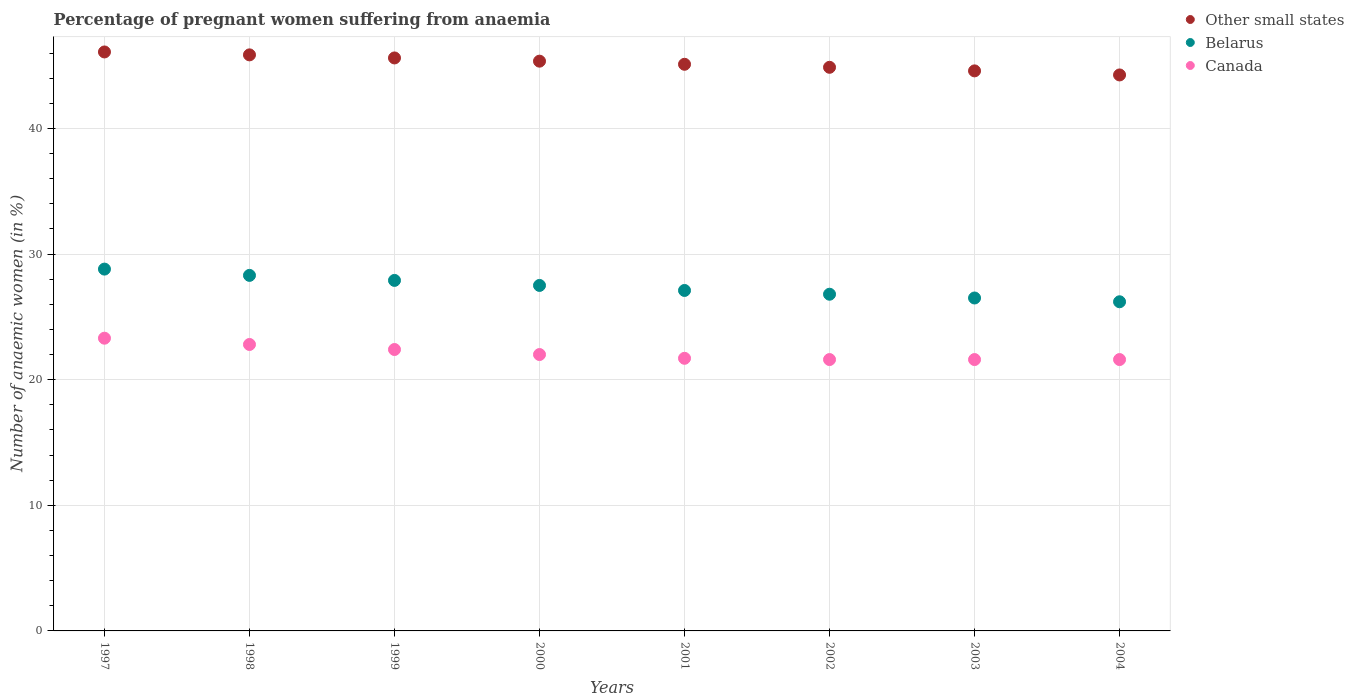How many different coloured dotlines are there?
Keep it short and to the point. 3. Is the number of dotlines equal to the number of legend labels?
Offer a terse response. Yes. What is the number of anaemic women in Belarus in 1998?
Offer a terse response. 28.3. Across all years, what is the maximum number of anaemic women in Canada?
Your answer should be compact. 23.3. Across all years, what is the minimum number of anaemic women in Canada?
Your response must be concise. 21.6. In which year was the number of anaemic women in Canada maximum?
Give a very brief answer. 1997. What is the total number of anaemic women in Belarus in the graph?
Offer a very short reply. 219.1. What is the difference between the number of anaemic women in Other small states in 2002 and the number of anaemic women in Canada in 2000?
Make the answer very short. 22.86. What is the average number of anaemic women in Canada per year?
Your answer should be compact. 22.12. In the year 2001, what is the difference between the number of anaemic women in Canada and number of anaemic women in Other small states?
Your answer should be very brief. -23.4. In how many years, is the number of anaemic women in Belarus greater than 24 %?
Your answer should be compact. 8. What is the ratio of the number of anaemic women in Other small states in 1998 to that in 2004?
Your answer should be very brief. 1.04. Is the number of anaemic women in Canada in 1998 less than that in 2002?
Ensure brevity in your answer.  No. What is the difference between the highest and the second highest number of anaemic women in Other small states?
Your response must be concise. 0.23. What is the difference between the highest and the lowest number of anaemic women in Canada?
Your response must be concise. 1.7. In how many years, is the number of anaemic women in Other small states greater than the average number of anaemic women in Other small states taken over all years?
Offer a very short reply. 4. Is the number of anaemic women in Belarus strictly greater than the number of anaemic women in Other small states over the years?
Offer a terse response. No. Is the number of anaemic women in Other small states strictly less than the number of anaemic women in Belarus over the years?
Offer a terse response. No. How many years are there in the graph?
Make the answer very short. 8. Where does the legend appear in the graph?
Provide a succinct answer. Top right. How are the legend labels stacked?
Offer a terse response. Vertical. What is the title of the graph?
Your answer should be very brief. Percentage of pregnant women suffering from anaemia. Does "Malawi" appear as one of the legend labels in the graph?
Your answer should be compact. No. What is the label or title of the X-axis?
Provide a short and direct response. Years. What is the label or title of the Y-axis?
Your response must be concise. Number of anaemic women (in %). What is the Number of anaemic women (in %) in Other small states in 1997?
Your answer should be very brief. 46.08. What is the Number of anaemic women (in %) in Belarus in 1997?
Offer a terse response. 28.8. What is the Number of anaemic women (in %) in Canada in 1997?
Offer a terse response. 23.3. What is the Number of anaemic women (in %) of Other small states in 1998?
Give a very brief answer. 45.85. What is the Number of anaemic women (in %) of Belarus in 1998?
Your answer should be compact. 28.3. What is the Number of anaemic women (in %) in Canada in 1998?
Provide a succinct answer. 22.8. What is the Number of anaemic women (in %) of Other small states in 1999?
Make the answer very short. 45.61. What is the Number of anaemic women (in %) of Belarus in 1999?
Offer a terse response. 27.9. What is the Number of anaemic women (in %) of Canada in 1999?
Make the answer very short. 22.4. What is the Number of anaemic women (in %) of Other small states in 2000?
Ensure brevity in your answer.  45.35. What is the Number of anaemic women (in %) in Belarus in 2000?
Your answer should be compact. 27.5. What is the Number of anaemic women (in %) of Other small states in 2001?
Give a very brief answer. 45.1. What is the Number of anaemic women (in %) in Belarus in 2001?
Ensure brevity in your answer.  27.1. What is the Number of anaemic women (in %) in Canada in 2001?
Offer a terse response. 21.7. What is the Number of anaemic women (in %) in Other small states in 2002?
Ensure brevity in your answer.  44.86. What is the Number of anaemic women (in %) in Belarus in 2002?
Keep it short and to the point. 26.8. What is the Number of anaemic women (in %) in Canada in 2002?
Keep it short and to the point. 21.6. What is the Number of anaemic women (in %) of Other small states in 2003?
Offer a very short reply. 44.58. What is the Number of anaemic women (in %) of Belarus in 2003?
Your answer should be compact. 26.5. What is the Number of anaemic women (in %) of Canada in 2003?
Keep it short and to the point. 21.6. What is the Number of anaemic women (in %) in Other small states in 2004?
Ensure brevity in your answer.  44.25. What is the Number of anaemic women (in %) of Belarus in 2004?
Your answer should be very brief. 26.2. What is the Number of anaemic women (in %) in Canada in 2004?
Ensure brevity in your answer.  21.6. Across all years, what is the maximum Number of anaemic women (in %) of Other small states?
Ensure brevity in your answer.  46.08. Across all years, what is the maximum Number of anaemic women (in %) of Belarus?
Offer a very short reply. 28.8. Across all years, what is the maximum Number of anaemic women (in %) of Canada?
Make the answer very short. 23.3. Across all years, what is the minimum Number of anaemic women (in %) in Other small states?
Keep it short and to the point. 44.25. Across all years, what is the minimum Number of anaemic women (in %) in Belarus?
Make the answer very short. 26.2. Across all years, what is the minimum Number of anaemic women (in %) of Canada?
Offer a very short reply. 21.6. What is the total Number of anaemic women (in %) of Other small states in the graph?
Your response must be concise. 361.7. What is the total Number of anaemic women (in %) in Belarus in the graph?
Your response must be concise. 219.1. What is the total Number of anaemic women (in %) in Canada in the graph?
Offer a terse response. 177. What is the difference between the Number of anaemic women (in %) of Other small states in 1997 and that in 1998?
Ensure brevity in your answer.  0.23. What is the difference between the Number of anaemic women (in %) in Belarus in 1997 and that in 1998?
Provide a succinct answer. 0.5. What is the difference between the Number of anaemic women (in %) in Other small states in 1997 and that in 1999?
Your answer should be very brief. 0.48. What is the difference between the Number of anaemic women (in %) of Belarus in 1997 and that in 1999?
Give a very brief answer. 0.9. What is the difference between the Number of anaemic women (in %) in Canada in 1997 and that in 1999?
Provide a succinct answer. 0.9. What is the difference between the Number of anaemic women (in %) of Other small states in 1997 and that in 2000?
Offer a very short reply. 0.73. What is the difference between the Number of anaemic women (in %) of Canada in 1997 and that in 2000?
Your answer should be very brief. 1.3. What is the difference between the Number of anaemic women (in %) in Other small states in 1997 and that in 2001?
Offer a very short reply. 0.98. What is the difference between the Number of anaemic women (in %) in Belarus in 1997 and that in 2001?
Your answer should be very brief. 1.7. What is the difference between the Number of anaemic women (in %) of Other small states in 1997 and that in 2002?
Keep it short and to the point. 1.22. What is the difference between the Number of anaemic women (in %) of Belarus in 1997 and that in 2002?
Provide a succinct answer. 2. What is the difference between the Number of anaemic women (in %) in Other small states in 1997 and that in 2003?
Your response must be concise. 1.51. What is the difference between the Number of anaemic women (in %) in Belarus in 1997 and that in 2003?
Give a very brief answer. 2.3. What is the difference between the Number of anaemic women (in %) of Canada in 1997 and that in 2003?
Keep it short and to the point. 1.7. What is the difference between the Number of anaemic women (in %) in Other small states in 1997 and that in 2004?
Ensure brevity in your answer.  1.83. What is the difference between the Number of anaemic women (in %) in Other small states in 1998 and that in 1999?
Make the answer very short. 0.24. What is the difference between the Number of anaemic women (in %) in Belarus in 1998 and that in 1999?
Offer a terse response. 0.4. What is the difference between the Number of anaemic women (in %) of Other small states in 1998 and that in 2000?
Give a very brief answer. 0.5. What is the difference between the Number of anaemic women (in %) in Canada in 1998 and that in 2000?
Your answer should be compact. 0.8. What is the difference between the Number of anaemic women (in %) of Other small states in 1998 and that in 2001?
Your answer should be compact. 0.75. What is the difference between the Number of anaemic women (in %) in Other small states in 1998 and that in 2002?
Provide a succinct answer. 0.99. What is the difference between the Number of anaemic women (in %) of Other small states in 1998 and that in 2003?
Your answer should be compact. 1.27. What is the difference between the Number of anaemic women (in %) in Belarus in 1998 and that in 2003?
Your answer should be compact. 1.8. What is the difference between the Number of anaemic women (in %) in Other small states in 1998 and that in 2004?
Ensure brevity in your answer.  1.6. What is the difference between the Number of anaemic women (in %) in Other small states in 1999 and that in 2000?
Offer a very short reply. 0.26. What is the difference between the Number of anaemic women (in %) in Other small states in 1999 and that in 2001?
Give a very brief answer. 0.5. What is the difference between the Number of anaemic women (in %) in Belarus in 1999 and that in 2001?
Make the answer very short. 0.8. What is the difference between the Number of anaemic women (in %) of Canada in 1999 and that in 2001?
Offer a terse response. 0.7. What is the difference between the Number of anaemic women (in %) of Other small states in 1999 and that in 2002?
Give a very brief answer. 0.75. What is the difference between the Number of anaemic women (in %) in Belarus in 1999 and that in 2002?
Provide a short and direct response. 1.1. What is the difference between the Number of anaemic women (in %) in Other small states in 1999 and that in 2003?
Offer a very short reply. 1.03. What is the difference between the Number of anaemic women (in %) in Belarus in 1999 and that in 2003?
Offer a very short reply. 1.4. What is the difference between the Number of anaemic women (in %) of Canada in 1999 and that in 2003?
Your answer should be compact. 0.8. What is the difference between the Number of anaemic women (in %) in Other small states in 1999 and that in 2004?
Provide a short and direct response. 1.35. What is the difference between the Number of anaemic women (in %) of Canada in 1999 and that in 2004?
Give a very brief answer. 0.8. What is the difference between the Number of anaemic women (in %) of Other small states in 2000 and that in 2001?
Ensure brevity in your answer.  0.25. What is the difference between the Number of anaemic women (in %) in Other small states in 2000 and that in 2002?
Keep it short and to the point. 0.49. What is the difference between the Number of anaemic women (in %) in Belarus in 2000 and that in 2002?
Ensure brevity in your answer.  0.7. What is the difference between the Number of anaemic women (in %) of Other small states in 2000 and that in 2003?
Your response must be concise. 0.77. What is the difference between the Number of anaemic women (in %) of Belarus in 2000 and that in 2003?
Ensure brevity in your answer.  1. What is the difference between the Number of anaemic women (in %) in Canada in 2000 and that in 2003?
Offer a terse response. 0.4. What is the difference between the Number of anaemic women (in %) of Other small states in 2000 and that in 2004?
Give a very brief answer. 1.1. What is the difference between the Number of anaemic women (in %) in Belarus in 2000 and that in 2004?
Offer a very short reply. 1.3. What is the difference between the Number of anaemic women (in %) in Canada in 2000 and that in 2004?
Your response must be concise. 0.4. What is the difference between the Number of anaemic women (in %) in Other small states in 2001 and that in 2002?
Make the answer very short. 0.24. What is the difference between the Number of anaemic women (in %) in Other small states in 2001 and that in 2003?
Ensure brevity in your answer.  0.52. What is the difference between the Number of anaemic women (in %) in Other small states in 2001 and that in 2004?
Offer a terse response. 0.85. What is the difference between the Number of anaemic women (in %) in Canada in 2001 and that in 2004?
Make the answer very short. 0.1. What is the difference between the Number of anaemic women (in %) of Other small states in 2002 and that in 2003?
Your answer should be very brief. 0.28. What is the difference between the Number of anaemic women (in %) of Other small states in 2002 and that in 2004?
Keep it short and to the point. 0.61. What is the difference between the Number of anaemic women (in %) in Canada in 2002 and that in 2004?
Keep it short and to the point. 0. What is the difference between the Number of anaemic women (in %) of Other small states in 2003 and that in 2004?
Your response must be concise. 0.32. What is the difference between the Number of anaemic women (in %) in Other small states in 1997 and the Number of anaemic women (in %) in Belarus in 1998?
Keep it short and to the point. 17.78. What is the difference between the Number of anaemic women (in %) of Other small states in 1997 and the Number of anaemic women (in %) of Canada in 1998?
Provide a succinct answer. 23.28. What is the difference between the Number of anaemic women (in %) of Belarus in 1997 and the Number of anaemic women (in %) of Canada in 1998?
Provide a short and direct response. 6. What is the difference between the Number of anaemic women (in %) of Other small states in 1997 and the Number of anaemic women (in %) of Belarus in 1999?
Provide a succinct answer. 18.18. What is the difference between the Number of anaemic women (in %) in Other small states in 1997 and the Number of anaemic women (in %) in Canada in 1999?
Offer a terse response. 23.68. What is the difference between the Number of anaemic women (in %) of Other small states in 1997 and the Number of anaemic women (in %) of Belarus in 2000?
Your response must be concise. 18.58. What is the difference between the Number of anaemic women (in %) of Other small states in 1997 and the Number of anaemic women (in %) of Canada in 2000?
Offer a terse response. 24.08. What is the difference between the Number of anaemic women (in %) in Other small states in 1997 and the Number of anaemic women (in %) in Belarus in 2001?
Your response must be concise. 18.98. What is the difference between the Number of anaemic women (in %) in Other small states in 1997 and the Number of anaemic women (in %) in Canada in 2001?
Make the answer very short. 24.38. What is the difference between the Number of anaemic women (in %) in Other small states in 1997 and the Number of anaemic women (in %) in Belarus in 2002?
Make the answer very short. 19.28. What is the difference between the Number of anaemic women (in %) in Other small states in 1997 and the Number of anaemic women (in %) in Canada in 2002?
Give a very brief answer. 24.48. What is the difference between the Number of anaemic women (in %) in Other small states in 1997 and the Number of anaemic women (in %) in Belarus in 2003?
Provide a short and direct response. 19.58. What is the difference between the Number of anaemic women (in %) of Other small states in 1997 and the Number of anaemic women (in %) of Canada in 2003?
Give a very brief answer. 24.48. What is the difference between the Number of anaemic women (in %) in Other small states in 1997 and the Number of anaemic women (in %) in Belarus in 2004?
Make the answer very short. 19.88. What is the difference between the Number of anaemic women (in %) in Other small states in 1997 and the Number of anaemic women (in %) in Canada in 2004?
Offer a very short reply. 24.48. What is the difference between the Number of anaemic women (in %) of Belarus in 1997 and the Number of anaemic women (in %) of Canada in 2004?
Offer a terse response. 7.2. What is the difference between the Number of anaemic women (in %) of Other small states in 1998 and the Number of anaemic women (in %) of Belarus in 1999?
Your response must be concise. 17.95. What is the difference between the Number of anaemic women (in %) of Other small states in 1998 and the Number of anaemic women (in %) of Canada in 1999?
Ensure brevity in your answer.  23.45. What is the difference between the Number of anaemic women (in %) in Belarus in 1998 and the Number of anaemic women (in %) in Canada in 1999?
Provide a succinct answer. 5.9. What is the difference between the Number of anaemic women (in %) in Other small states in 1998 and the Number of anaemic women (in %) in Belarus in 2000?
Make the answer very short. 18.35. What is the difference between the Number of anaemic women (in %) in Other small states in 1998 and the Number of anaemic women (in %) in Canada in 2000?
Provide a succinct answer. 23.85. What is the difference between the Number of anaemic women (in %) of Other small states in 1998 and the Number of anaemic women (in %) of Belarus in 2001?
Provide a short and direct response. 18.75. What is the difference between the Number of anaemic women (in %) of Other small states in 1998 and the Number of anaemic women (in %) of Canada in 2001?
Provide a succinct answer. 24.15. What is the difference between the Number of anaemic women (in %) of Other small states in 1998 and the Number of anaemic women (in %) of Belarus in 2002?
Provide a short and direct response. 19.05. What is the difference between the Number of anaemic women (in %) of Other small states in 1998 and the Number of anaemic women (in %) of Canada in 2002?
Offer a very short reply. 24.25. What is the difference between the Number of anaemic women (in %) in Other small states in 1998 and the Number of anaemic women (in %) in Belarus in 2003?
Offer a very short reply. 19.35. What is the difference between the Number of anaemic women (in %) in Other small states in 1998 and the Number of anaemic women (in %) in Canada in 2003?
Make the answer very short. 24.25. What is the difference between the Number of anaemic women (in %) of Belarus in 1998 and the Number of anaemic women (in %) of Canada in 2003?
Your answer should be compact. 6.7. What is the difference between the Number of anaemic women (in %) in Other small states in 1998 and the Number of anaemic women (in %) in Belarus in 2004?
Offer a terse response. 19.65. What is the difference between the Number of anaemic women (in %) in Other small states in 1998 and the Number of anaemic women (in %) in Canada in 2004?
Provide a short and direct response. 24.25. What is the difference between the Number of anaemic women (in %) of Other small states in 1999 and the Number of anaemic women (in %) of Belarus in 2000?
Provide a short and direct response. 18.11. What is the difference between the Number of anaemic women (in %) of Other small states in 1999 and the Number of anaemic women (in %) of Canada in 2000?
Give a very brief answer. 23.61. What is the difference between the Number of anaemic women (in %) of Other small states in 1999 and the Number of anaemic women (in %) of Belarus in 2001?
Your response must be concise. 18.51. What is the difference between the Number of anaemic women (in %) in Other small states in 1999 and the Number of anaemic women (in %) in Canada in 2001?
Your response must be concise. 23.91. What is the difference between the Number of anaemic women (in %) in Belarus in 1999 and the Number of anaemic women (in %) in Canada in 2001?
Offer a very short reply. 6.2. What is the difference between the Number of anaemic women (in %) of Other small states in 1999 and the Number of anaemic women (in %) of Belarus in 2002?
Your answer should be very brief. 18.81. What is the difference between the Number of anaemic women (in %) in Other small states in 1999 and the Number of anaemic women (in %) in Canada in 2002?
Offer a very short reply. 24.01. What is the difference between the Number of anaemic women (in %) in Belarus in 1999 and the Number of anaemic women (in %) in Canada in 2002?
Provide a short and direct response. 6.3. What is the difference between the Number of anaemic women (in %) in Other small states in 1999 and the Number of anaemic women (in %) in Belarus in 2003?
Provide a short and direct response. 19.11. What is the difference between the Number of anaemic women (in %) in Other small states in 1999 and the Number of anaemic women (in %) in Canada in 2003?
Give a very brief answer. 24.01. What is the difference between the Number of anaemic women (in %) of Belarus in 1999 and the Number of anaemic women (in %) of Canada in 2003?
Offer a very short reply. 6.3. What is the difference between the Number of anaemic women (in %) in Other small states in 1999 and the Number of anaemic women (in %) in Belarus in 2004?
Your answer should be compact. 19.41. What is the difference between the Number of anaemic women (in %) of Other small states in 1999 and the Number of anaemic women (in %) of Canada in 2004?
Provide a succinct answer. 24.01. What is the difference between the Number of anaemic women (in %) of Belarus in 1999 and the Number of anaemic women (in %) of Canada in 2004?
Provide a succinct answer. 6.3. What is the difference between the Number of anaemic women (in %) in Other small states in 2000 and the Number of anaemic women (in %) in Belarus in 2001?
Provide a succinct answer. 18.25. What is the difference between the Number of anaemic women (in %) of Other small states in 2000 and the Number of anaemic women (in %) of Canada in 2001?
Make the answer very short. 23.65. What is the difference between the Number of anaemic women (in %) of Other small states in 2000 and the Number of anaemic women (in %) of Belarus in 2002?
Provide a short and direct response. 18.55. What is the difference between the Number of anaemic women (in %) of Other small states in 2000 and the Number of anaemic women (in %) of Canada in 2002?
Offer a very short reply. 23.75. What is the difference between the Number of anaemic women (in %) of Belarus in 2000 and the Number of anaemic women (in %) of Canada in 2002?
Your answer should be very brief. 5.9. What is the difference between the Number of anaemic women (in %) of Other small states in 2000 and the Number of anaemic women (in %) of Belarus in 2003?
Give a very brief answer. 18.85. What is the difference between the Number of anaemic women (in %) in Other small states in 2000 and the Number of anaemic women (in %) in Canada in 2003?
Provide a succinct answer. 23.75. What is the difference between the Number of anaemic women (in %) in Belarus in 2000 and the Number of anaemic women (in %) in Canada in 2003?
Give a very brief answer. 5.9. What is the difference between the Number of anaemic women (in %) in Other small states in 2000 and the Number of anaemic women (in %) in Belarus in 2004?
Your response must be concise. 19.15. What is the difference between the Number of anaemic women (in %) in Other small states in 2000 and the Number of anaemic women (in %) in Canada in 2004?
Give a very brief answer. 23.75. What is the difference between the Number of anaemic women (in %) in Other small states in 2001 and the Number of anaemic women (in %) in Belarus in 2002?
Keep it short and to the point. 18.3. What is the difference between the Number of anaemic women (in %) of Other small states in 2001 and the Number of anaemic women (in %) of Canada in 2002?
Provide a succinct answer. 23.5. What is the difference between the Number of anaemic women (in %) of Other small states in 2001 and the Number of anaemic women (in %) of Belarus in 2003?
Make the answer very short. 18.6. What is the difference between the Number of anaemic women (in %) in Other small states in 2001 and the Number of anaemic women (in %) in Canada in 2003?
Give a very brief answer. 23.5. What is the difference between the Number of anaemic women (in %) in Other small states in 2001 and the Number of anaemic women (in %) in Belarus in 2004?
Your answer should be very brief. 18.9. What is the difference between the Number of anaemic women (in %) in Other small states in 2001 and the Number of anaemic women (in %) in Canada in 2004?
Offer a terse response. 23.5. What is the difference between the Number of anaemic women (in %) in Belarus in 2001 and the Number of anaemic women (in %) in Canada in 2004?
Give a very brief answer. 5.5. What is the difference between the Number of anaemic women (in %) of Other small states in 2002 and the Number of anaemic women (in %) of Belarus in 2003?
Give a very brief answer. 18.36. What is the difference between the Number of anaemic women (in %) in Other small states in 2002 and the Number of anaemic women (in %) in Canada in 2003?
Provide a succinct answer. 23.26. What is the difference between the Number of anaemic women (in %) of Belarus in 2002 and the Number of anaemic women (in %) of Canada in 2003?
Keep it short and to the point. 5.2. What is the difference between the Number of anaemic women (in %) in Other small states in 2002 and the Number of anaemic women (in %) in Belarus in 2004?
Provide a short and direct response. 18.66. What is the difference between the Number of anaemic women (in %) of Other small states in 2002 and the Number of anaemic women (in %) of Canada in 2004?
Offer a terse response. 23.26. What is the difference between the Number of anaemic women (in %) of Belarus in 2002 and the Number of anaemic women (in %) of Canada in 2004?
Ensure brevity in your answer.  5.2. What is the difference between the Number of anaemic women (in %) of Other small states in 2003 and the Number of anaemic women (in %) of Belarus in 2004?
Your answer should be very brief. 18.38. What is the difference between the Number of anaemic women (in %) of Other small states in 2003 and the Number of anaemic women (in %) of Canada in 2004?
Offer a terse response. 22.98. What is the average Number of anaemic women (in %) in Other small states per year?
Provide a short and direct response. 45.21. What is the average Number of anaemic women (in %) in Belarus per year?
Keep it short and to the point. 27.39. What is the average Number of anaemic women (in %) in Canada per year?
Your answer should be very brief. 22.12. In the year 1997, what is the difference between the Number of anaemic women (in %) in Other small states and Number of anaemic women (in %) in Belarus?
Make the answer very short. 17.28. In the year 1997, what is the difference between the Number of anaemic women (in %) of Other small states and Number of anaemic women (in %) of Canada?
Keep it short and to the point. 22.78. In the year 1998, what is the difference between the Number of anaemic women (in %) in Other small states and Number of anaemic women (in %) in Belarus?
Offer a very short reply. 17.55. In the year 1998, what is the difference between the Number of anaemic women (in %) in Other small states and Number of anaemic women (in %) in Canada?
Offer a very short reply. 23.05. In the year 1999, what is the difference between the Number of anaemic women (in %) of Other small states and Number of anaemic women (in %) of Belarus?
Offer a terse response. 17.71. In the year 1999, what is the difference between the Number of anaemic women (in %) in Other small states and Number of anaemic women (in %) in Canada?
Offer a very short reply. 23.21. In the year 2000, what is the difference between the Number of anaemic women (in %) of Other small states and Number of anaemic women (in %) of Belarus?
Give a very brief answer. 17.85. In the year 2000, what is the difference between the Number of anaemic women (in %) in Other small states and Number of anaemic women (in %) in Canada?
Make the answer very short. 23.35. In the year 2000, what is the difference between the Number of anaemic women (in %) in Belarus and Number of anaemic women (in %) in Canada?
Provide a succinct answer. 5.5. In the year 2001, what is the difference between the Number of anaemic women (in %) in Other small states and Number of anaemic women (in %) in Belarus?
Give a very brief answer. 18. In the year 2001, what is the difference between the Number of anaemic women (in %) of Other small states and Number of anaemic women (in %) of Canada?
Provide a short and direct response. 23.4. In the year 2002, what is the difference between the Number of anaemic women (in %) in Other small states and Number of anaemic women (in %) in Belarus?
Your answer should be compact. 18.06. In the year 2002, what is the difference between the Number of anaemic women (in %) of Other small states and Number of anaemic women (in %) of Canada?
Make the answer very short. 23.26. In the year 2003, what is the difference between the Number of anaemic women (in %) of Other small states and Number of anaemic women (in %) of Belarus?
Provide a succinct answer. 18.08. In the year 2003, what is the difference between the Number of anaemic women (in %) of Other small states and Number of anaemic women (in %) of Canada?
Provide a short and direct response. 22.98. In the year 2004, what is the difference between the Number of anaemic women (in %) of Other small states and Number of anaemic women (in %) of Belarus?
Your answer should be very brief. 18.05. In the year 2004, what is the difference between the Number of anaemic women (in %) of Other small states and Number of anaemic women (in %) of Canada?
Make the answer very short. 22.65. In the year 2004, what is the difference between the Number of anaemic women (in %) of Belarus and Number of anaemic women (in %) of Canada?
Make the answer very short. 4.6. What is the ratio of the Number of anaemic women (in %) of Other small states in 1997 to that in 1998?
Your answer should be compact. 1.01. What is the ratio of the Number of anaemic women (in %) of Belarus in 1997 to that in 1998?
Offer a terse response. 1.02. What is the ratio of the Number of anaemic women (in %) in Canada in 1997 to that in 1998?
Provide a short and direct response. 1.02. What is the ratio of the Number of anaemic women (in %) in Other small states in 1997 to that in 1999?
Your answer should be compact. 1.01. What is the ratio of the Number of anaemic women (in %) in Belarus in 1997 to that in 1999?
Your answer should be compact. 1.03. What is the ratio of the Number of anaemic women (in %) of Canada in 1997 to that in 1999?
Provide a succinct answer. 1.04. What is the ratio of the Number of anaemic women (in %) in Other small states in 1997 to that in 2000?
Give a very brief answer. 1.02. What is the ratio of the Number of anaemic women (in %) in Belarus in 1997 to that in 2000?
Your answer should be compact. 1.05. What is the ratio of the Number of anaemic women (in %) of Canada in 1997 to that in 2000?
Offer a terse response. 1.06. What is the ratio of the Number of anaemic women (in %) in Other small states in 1997 to that in 2001?
Offer a very short reply. 1.02. What is the ratio of the Number of anaemic women (in %) of Belarus in 1997 to that in 2001?
Keep it short and to the point. 1.06. What is the ratio of the Number of anaemic women (in %) in Canada in 1997 to that in 2001?
Your response must be concise. 1.07. What is the ratio of the Number of anaemic women (in %) in Other small states in 1997 to that in 2002?
Your response must be concise. 1.03. What is the ratio of the Number of anaemic women (in %) in Belarus in 1997 to that in 2002?
Your answer should be very brief. 1.07. What is the ratio of the Number of anaemic women (in %) of Canada in 1997 to that in 2002?
Provide a short and direct response. 1.08. What is the ratio of the Number of anaemic women (in %) of Other small states in 1997 to that in 2003?
Offer a very short reply. 1.03. What is the ratio of the Number of anaemic women (in %) in Belarus in 1997 to that in 2003?
Your answer should be compact. 1.09. What is the ratio of the Number of anaemic women (in %) of Canada in 1997 to that in 2003?
Give a very brief answer. 1.08. What is the ratio of the Number of anaemic women (in %) in Other small states in 1997 to that in 2004?
Make the answer very short. 1.04. What is the ratio of the Number of anaemic women (in %) in Belarus in 1997 to that in 2004?
Give a very brief answer. 1.1. What is the ratio of the Number of anaemic women (in %) in Canada in 1997 to that in 2004?
Keep it short and to the point. 1.08. What is the ratio of the Number of anaemic women (in %) of Other small states in 1998 to that in 1999?
Your answer should be compact. 1.01. What is the ratio of the Number of anaemic women (in %) of Belarus in 1998 to that in 1999?
Give a very brief answer. 1.01. What is the ratio of the Number of anaemic women (in %) of Canada in 1998 to that in 1999?
Offer a terse response. 1.02. What is the ratio of the Number of anaemic women (in %) of Other small states in 1998 to that in 2000?
Ensure brevity in your answer.  1.01. What is the ratio of the Number of anaemic women (in %) of Belarus in 1998 to that in 2000?
Offer a terse response. 1.03. What is the ratio of the Number of anaemic women (in %) in Canada in 1998 to that in 2000?
Offer a terse response. 1.04. What is the ratio of the Number of anaemic women (in %) in Other small states in 1998 to that in 2001?
Give a very brief answer. 1.02. What is the ratio of the Number of anaemic women (in %) of Belarus in 1998 to that in 2001?
Offer a terse response. 1.04. What is the ratio of the Number of anaemic women (in %) of Canada in 1998 to that in 2001?
Your answer should be compact. 1.05. What is the ratio of the Number of anaemic women (in %) in Other small states in 1998 to that in 2002?
Offer a very short reply. 1.02. What is the ratio of the Number of anaemic women (in %) of Belarus in 1998 to that in 2002?
Make the answer very short. 1.06. What is the ratio of the Number of anaemic women (in %) in Canada in 1998 to that in 2002?
Offer a very short reply. 1.06. What is the ratio of the Number of anaemic women (in %) in Other small states in 1998 to that in 2003?
Provide a short and direct response. 1.03. What is the ratio of the Number of anaemic women (in %) in Belarus in 1998 to that in 2003?
Your response must be concise. 1.07. What is the ratio of the Number of anaemic women (in %) in Canada in 1998 to that in 2003?
Give a very brief answer. 1.06. What is the ratio of the Number of anaemic women (in %) in Other small states in 1998 to that in 2004?
Your answer should be compact. 1.04. What is the ratio of the Number of anaemic women (in %) in Belarus in 1998 to that in 2004?
Your response must be concise. 1.08. What is the ratio of the Number of anaemic women (in %) of Canada in 1998 to that in 2004?
Offer a terse response. 1.06. What is the ratio of the Number of anaemic women (in %) in Belarus in 1999 to that in 2000?
Make the answer very short. 1.01. What is the ratio of the Number of anaemic women (in %) of Canada in 1999 to that in 2000?
Offer a very short reply. 1.02. What is the ratio of the Number of anaemic women (in %) of Other small states in 1999 to that in 2001?
Ensure brevity in your answer.  1.01. What is the ratio of the Number of anaemic women (in %) of Belarus in 1999 to that in 2001?
Your answer should be very brief. 1.03. What is the ratio of the Number of anaemic women (in %) in Canada in 1999 to that in 2001?
Provide a succinct answer. 1.03. What is the ratio of the Number of anaemic women (in %) of Other small states in 1999 to that in 2002?
Keep it short and to the point. 1.02. What is the ratio of the Number of anaemic women (in %) in Belarus in 1999 to that in 2002?
Your response must be concise. 1.04. What is the ratio of the Number of anaemic women (in %) of Other small states in 1999 to that in 2003?
Offer a very short reply. 1.02. What is the ratio of the Number of anaemic women (in %) in Belarus in 1999 to that in 2003?
Offer a very short reply. 1.05. What is the ratio of the Number of anaemic women (in %) of Canada in 1999 to that in 2003?
Make the answer very short. 1.04. What is the ratio of the Number of anaemic women (in %) of Other small states in 1999 to that in 2004?
Your answer should be compact. 1.03. What is the ratio of the Number of anaemic women (in %) of Belarus in 1999 to that in 2004?
Provide a short and direct response. 1.06. What is the ratio of the Number of anaemic women (in %) of Other small states in 2000 to that in 2001?
Your response must be concise. 1.01. What is the ratio of the Number of anaemic women (in %) of Belarus in 2000 to that in 2001?
Offer a very short reply. 1.01. What is the ratio of the Number of anaemic women (in %) in Canada in 2000 to that in 2001?
Keep it short and to the point. 1.01. What is the ratio of the Number of anaemic women (in %) in Other small states in 2000 to that in 2002?
Make the answer very short. 1.01. What is the ratio of the Number of anaemic women (in %) of Belarus in 2000 to that in 2002?
Your answer should be compact. 1.03. What is the ratio of the Number of anaemic women (in %) of Canada in 2000 to that in 2002?
Offer a very short reply. 1.02. What is the ratio of the Number of anaemic women (in %) of Other small states in 2000 to that in 2003?
Give a very brief answer. 1.02. What is the ratio of the Number of anaemic women (in %) in Belarus in 2000 to that in 2003?
Your answer should be very brief. 1.04. What is the ratio of the Number of anaemic women (in %) of Canada in 2000 to that in 2003?
Make the answer very short. 1.02. What is the ratio of the Number of anaemic women (in %) in Other small states in 2000 to that in 2004?
Provide a succinct answer. 1.02. What is the ratio of the Number of anaemic women (in %) of Belarus in 2000 to that in 2004?
Make the answer very short. 1.05. What is the ratio of the Number of anaemic women (in %) in Canada in 2000 to that in 2004?
Make the answer very short. 1.02. What is the ratio of the Number of anaemic women (in %) of Other small states in 2001 to that in 2002?
Your answer should be very brief. 1.01. What is the ratio of the Number of anaemic women (in %) of Belarus in 2001 to that in 2002?
Provide a short and direct response. 1.01. What is the ratio of the Number of anaemic women (in %) in Other small states in 2001 to that in 2003?
Offer a terse response. 1.01. What is the ratio of the Number of anaemic women (in %) in Belarus in 2001 to that in 2003?
Offer a terse response. 1.02. What is the ratio of the Number of anaemic women (in %) of Other small states in 2001 to that in 2004?
Provide a succinct answer. 1.02. What is the ratio of the Number of anaemic women (in %) of Belarus in 2001 to that in 2004?
Provide a short and direct response. 1.03. What is the ratio of the Number of anaemic women (in %) of Other small states in 2002 to that in 2003?
Your answer should be very brief. 1.01. What is the ratio of the Number of anaemic women (in %) in Belarus in 2002 to that in 2003?
Give a very brief answer. 1.01. What is the ratio of the Number of anaemic women (in %) in Canada in 2002 to that in 2003?
Provide a short and direct response. 1. What is the ratio of the Number of anaemic women (in %) of Other small states in 2002 to that in 2004?
Keep it short and to the point. 1.01. What is the ratio of the Number of anaemic women (in %) in Belarus in 2002 to that in 2004?
Your answer should be compact. 1.02. What is the ratio of the Number of anaemic women (in %) of Canada in 2002 to that in 2004?
Make the answer very short. 1. What is the ratio of the Number of anaemic women (in %) in Other small states in 2003 to that in 2004?
Your response must be concise. 1.01. What is the ratio of the Number of anaemic women (in %) of Belarus in 2003 to that in 2004?
Your response must be concise. 1.01. What is the difference between the highest and the second highest Number of anaemic women (in %) in Other small states?
Your response must be concise. 0.23. What is the difference between the highest and the lowest Number of anaemic women (in %) in Other small states?
Keep it short and to the point. 1.83. What is the difference between the highest and the lowest Number of anaemic women (in %) of Belarus?
Ensure brevity in your answer.  2.6. 